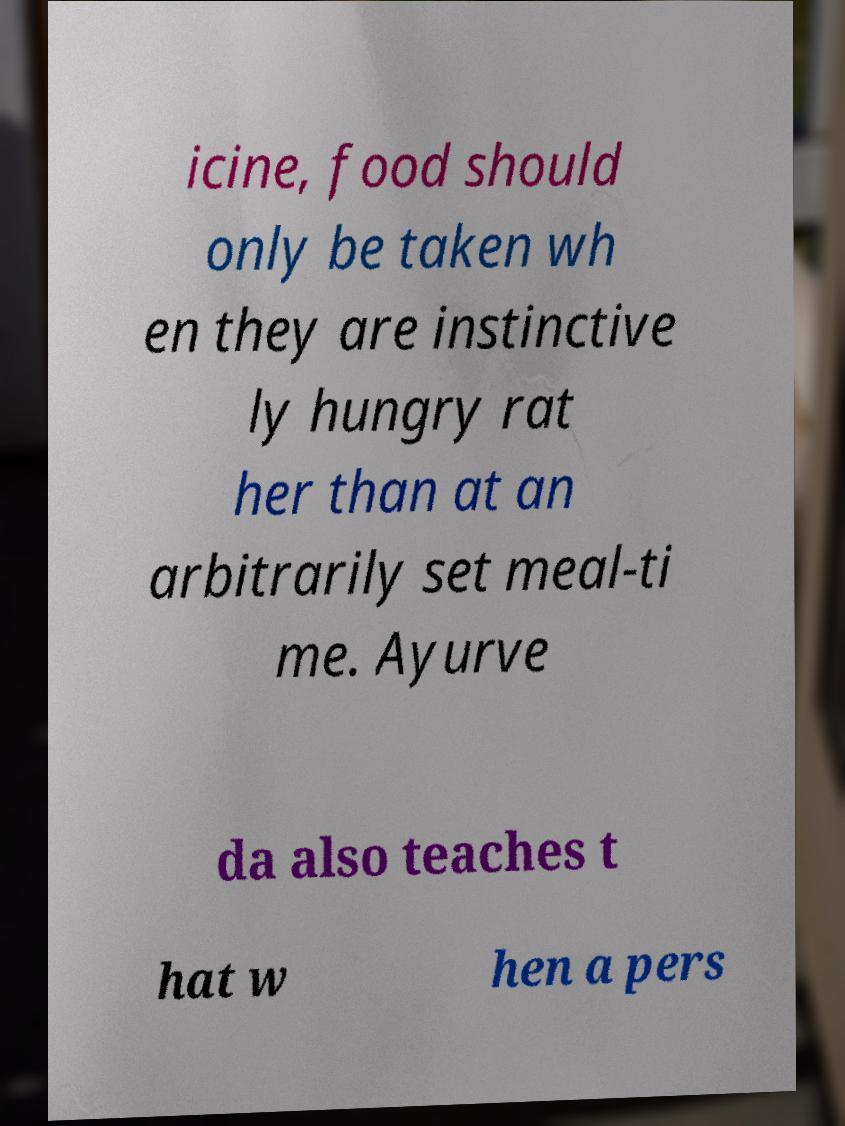Can you accurately transcribe the text from the provided image for me? icine, food should only be taken wh en they are instinctive ly hungry rat her than at an arbitrarily set meal-ti me. Ayurve da also teaches t hat w hen a pers 